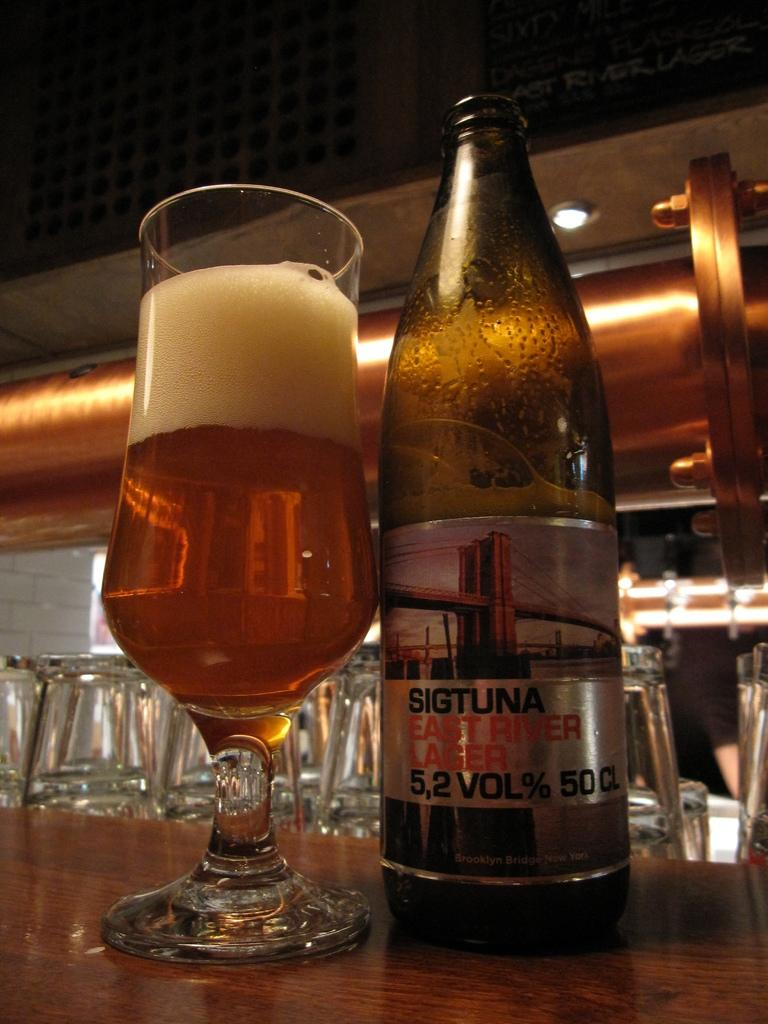<image>
Render a clear and concise summary of the photo. A bottle of Sigtuna East River Lager next to a glass of beer with a two inch foam head. 